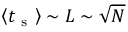<formula> <loc_0><loc_0><loc_500><loc_500>\left < t _ { s } \right > \sim L \sim \sqrt { N }</formula> 